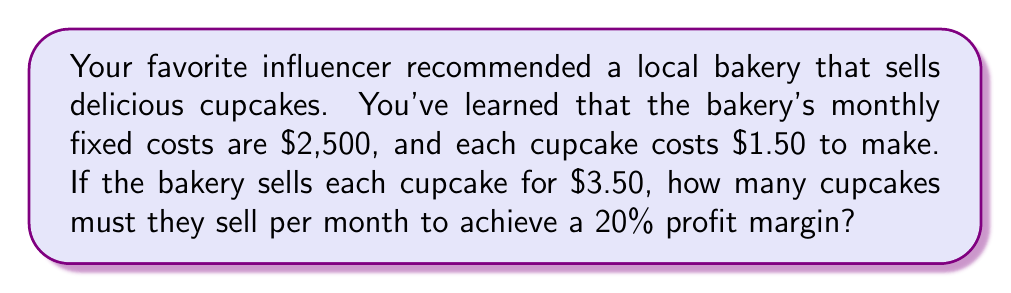Can you answer this question? Let's approach this step-by-step using linear equations:

1) Define variables:
   $x$ = number of cupcakes sold
   $y$ = total revenue
   $z$ = total costs

2) Set up the revenue equation:
   $y = 3.50x$

3) Set up the cost equation:
   $z = 2500 + 1.50x$

4) Profit is revenue minus costs:
   $\text{Profit} = y - z = 3.50x - (2500 + 1.50x) = 2x - 2500$

5) For a 20% profit margin, profit should be 20% of revenue:
   $2x - 2500 = 0.20(3.50x)$

6) Solve the equation:
   $2x - 2500 = 0.70x$
   $1.30x = 2500$
   $x = \frac{2500}{1.30} \approx 1923.08$

7) Since we can't sell a fraction of a cupcake, we round up to the nearest whole number:
   $x = 1924$ cupcakes
Answer: 1924 cupcakes 